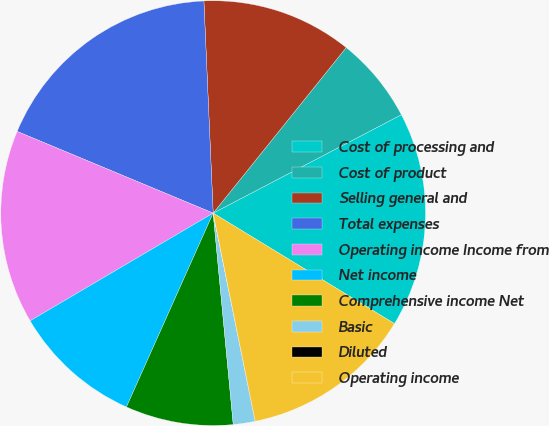<chart> <loc_0><loc_0><loc_500><loc_500><pie_chart><fcel>Cost of processing and<fcel>Cost of product<fcel>Selling general and<fcel>Total expenses<fcel>Operating income Income from<fcel>Net income<fcel>Comprehensive income Net<fcel>Basic<fcel>Diluted<fcel>Operating income<nl><fcel>16.38%<fcel>6.56%<fcel>11.47%<fcel>18.02%<fcel>14.75%<fcel>9.84%<fcel>8.2%<fcel>1.65%<fcel>0.02%<fcel>13.11%<nl></chart> 